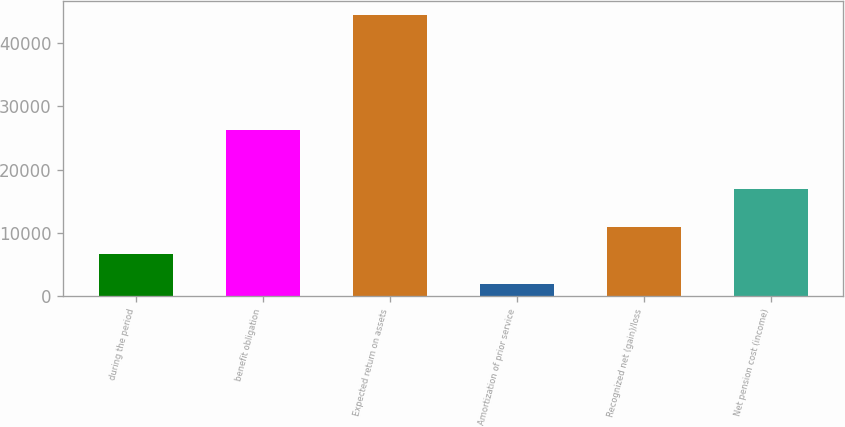<chart> <loc_0><loc_0><loc_500><loc_500><bar_chart><fcel>during the period<fcel>benefit obligation<fcel>Expected return on assets<fcel>Amortization of prior service<fcel>Recognized net (gain)/loss<fcel>Net pension cost (income)<nl><fcel>6645<fcel>26292<fcel>44511<fcel>1896<fcel>10906.5<fcel>16944<nl></chart> 